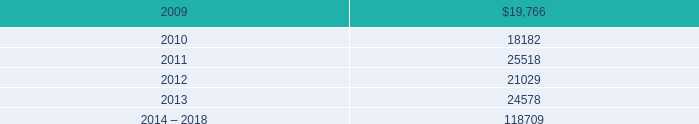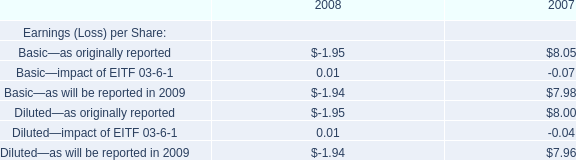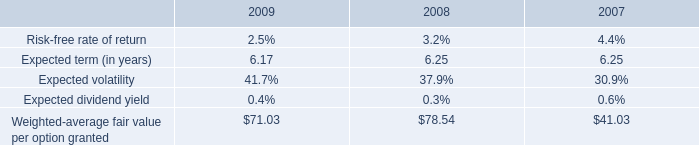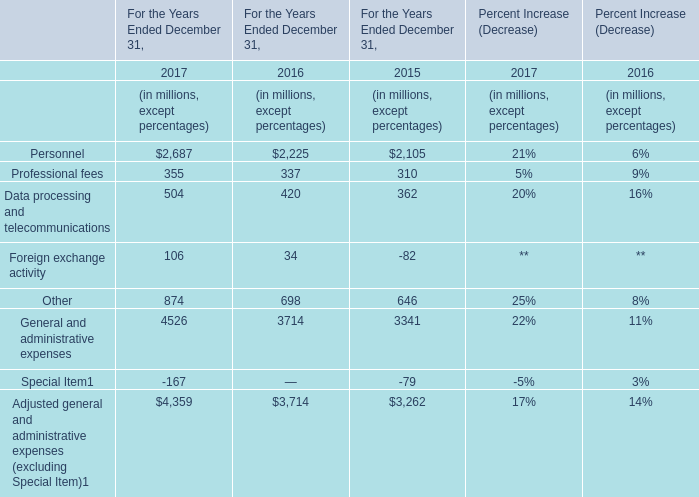What's the average of Adjusted general and administrative expenses (excluding Special Item) in 2016? (in million) 
Computations: (3714 / 7)
Answer: 530.57143. 